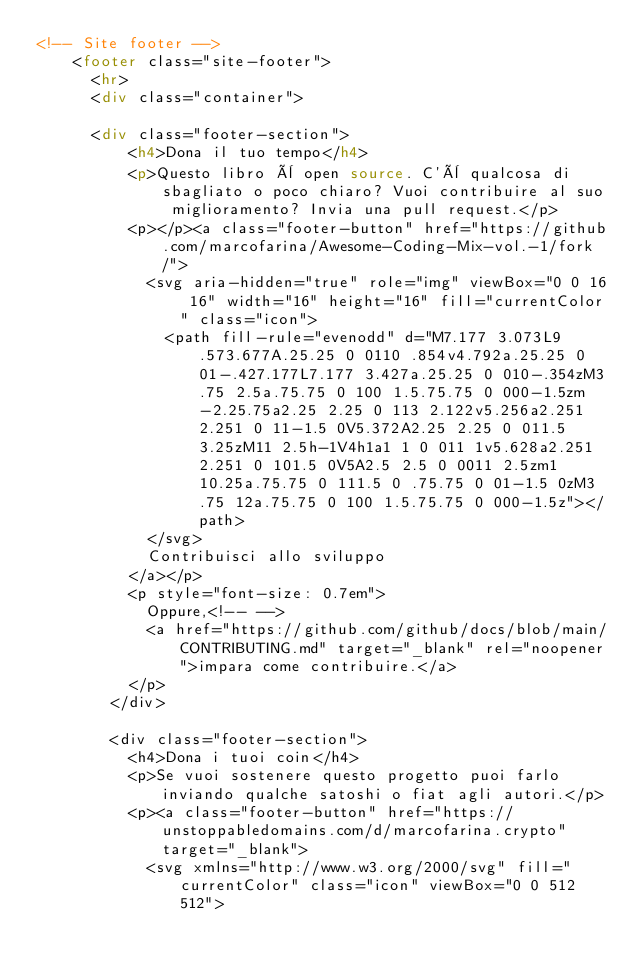<code> <loc_0><loc_0><loc_500><loc_500><_HTML_><!-- Site footer -->
		<footer class="site-footer">
			<hr>
			<div class="container">

    	<div class="footer-section">
					<h4>Dona il tuo tempo</h4>
					<p>Questo libro è open source. C'è qualcosa di sbagliato o poco chiaro? Vuoi contribuire al suo miglioramento? Invia una pull request.</p>
					<p></p><a class="footer-button" href="https://github.com/marcofarina/Awesome-Coding-Mix-vol.-1/fork/">
						<svg aria-hidden="true" role="img" viewBox="0 0 16 16" width="16" height="16" fill="currentColor" class="icon">
							<path fill-rule="evenodd" d="M7.177 3.073L9.573.677A.25.25 0 0110 .854v4.792a.25.25 0 01-.427.177L7.177 3.427a.25.25 0 010-.354zM3.75 2.5a.75.75 0 100 1.5.75.75 0 000-1.5zm-2.25.75a2.25 2.25 0 113 2.122v5.256a2.251 2.251 0 11-1.5 0V5.372A2.25 2.25 0 011.5 3.25zM11 2.5h-1V4h1a1 1 0 011 1v5.628a2.251 2.251 0 101.5 0V5A2.5 2.5 0 0011 2.5zm1 10.25a.75.75 0 111.5 0 .75.75 0 01-1.5 0zM3.75 12a.75.75 0 100 1.5.75.75 0 000-1.5z"></path>
						</svg>
						Contribuisci allo sviluppo
					</a></p>
					<p style="font-size: 0.7em">
						Oppure,<!-- -->
						<a href="https://github.com/github/docs/blob/main/CONTRIBUTING.md" target="_blank" rel="noopener">impara come contribuire.</a>
					</p>
				</div>

				<div class="footer-section">
					<h4>Dona i tuoi coin</h4>
					<p>Se vuoi sostenere questo progetto puoi farlo inviando qualche satoshi o fiat agli autori.</p>
					<p><a class="footer-button" href="https://unstoppabledomains.com/d/marcofarina.crypto" target="_blank">
						<svg xmlns="http://www.w3.org/2000/svg" fill="currentColor" class="icon" viewBox="0 0 512 512"></code> 